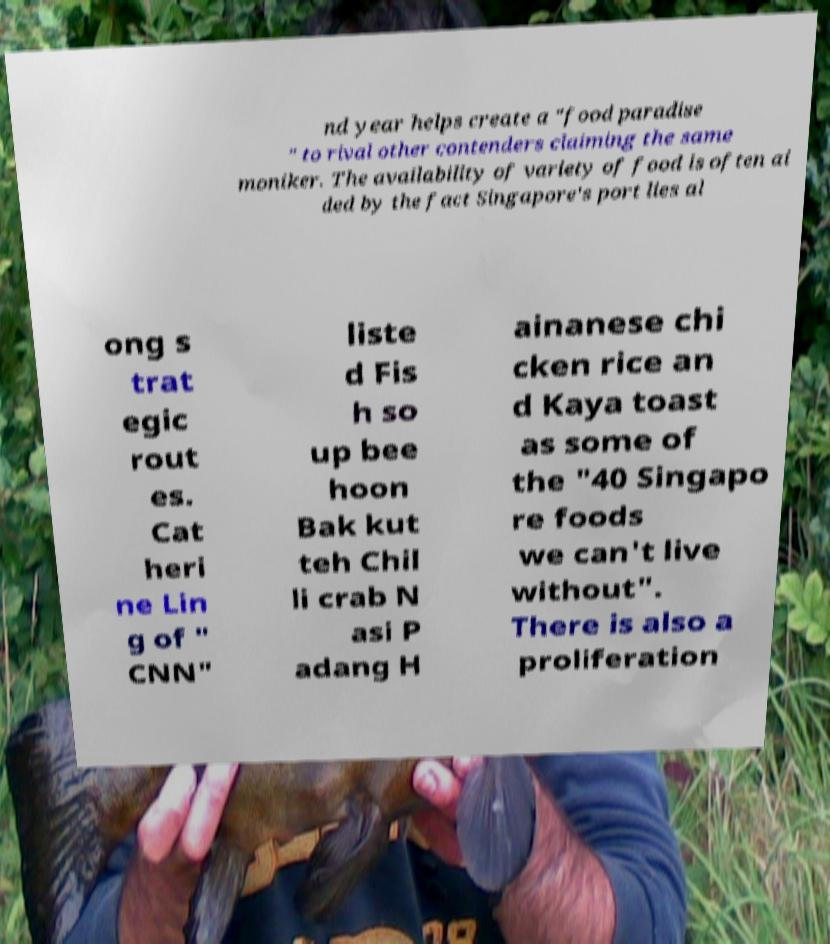Could you assist in decoding the text presented in this image and type it out clearly? nd year helps create a "food paradise " to rival other contenders claiming the same moniker. The availability of variety of food is often ai ded by the fact Singapore's port lies al ong s trat egic rout es. Cat heri ne Lin g of " CNN" liste d Fis h so up bee hoon Bak kut teh Chil li crab N asi P adang H ainanese chi cken rice an d Kaya toast as some of the "40 Singapo re foods we can't live without". There is also a proliferation 